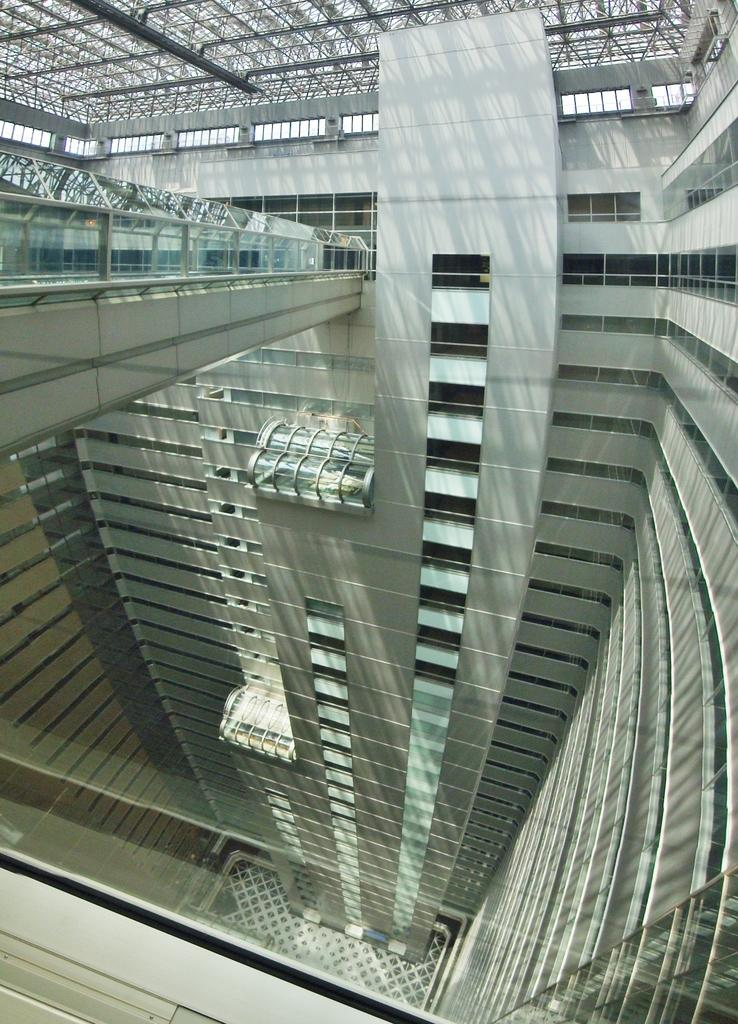What type of structure can be seen in the image? There is a building in the image. What reflective objects are present in the image? There are mirrors in the image. What type of metalwork is visible in the image? Iron grills are visible in the image. What type of architectural feature can be seen in the image? Railings are present in the image. How many wrens are perched on the railings in the image? There are no wrens present in the image. What type of edge can be seen on the mirrors in the image? The mirrors in the image do not have any visible edges. 